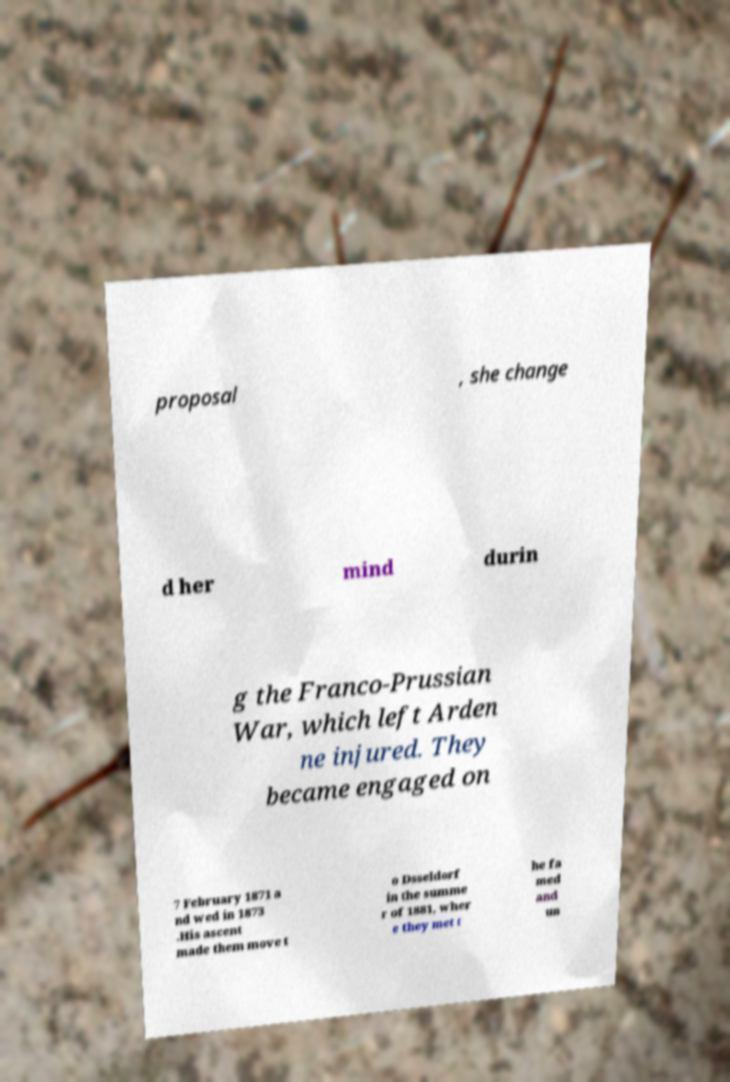Please identify and transcribe the text found in this image. proposal , she change d her mind durin g the Franco-Prussian War, which left Arden ne injured. They became engaged on 7 February 1871 a nd wed in 1873 .His ascent made them move t o Dsseldorf in the summe r of 1881, wher e they met t he fa med and un 